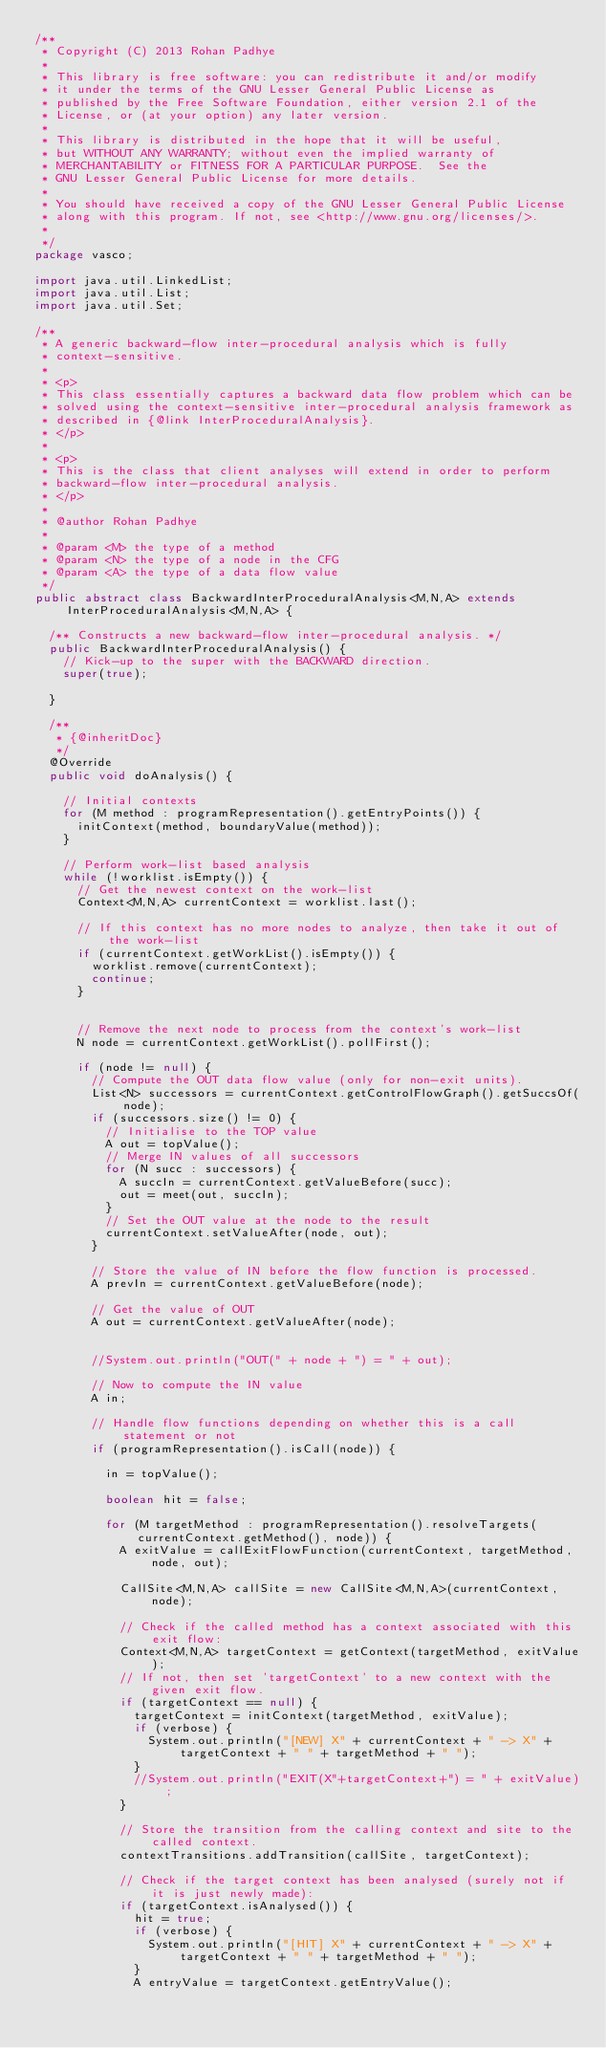<code> <loc_0><loc_0><loc_500><loc_500><_Java_>/**
 * Copyright (C) 2013 Rohan Padhye
 * 
 * This library is free software: you can redistribute it and/or modify
 * it under the terms of the GNU Lesser General Public License as 
 * published by the Free Software Foundation, either version 2.1 of the 
 * License, or (at your option) any later version.
 * 
 * This library is distributed in the hope that it will be useful,
 * but WITHOUT ANY WARRANTY; without even the implied warranty of
 * MERCHANTABILITY or FITNESS FOR A PARTICULAR PURPOSE.  See the
 * GNU Lesser General Public License for more details.
 * 
 * You should have received a copy of the GNU Lesser General Public License
 * along with this program. If not, see <http://www.gnu.org/licenses/>.
 * 
 */
package vasco;

import java.util.LinkedList;
import java.util.List;
import java.util.Set;

/**
 * A generic backward-flow inter-procedural analysis which is fully
 * context-sensitive.
 * 
 * <p>
 * This class essentially captures a backward data flow problem which can be
 * solved using the context-sensitive inter-procedural analysis framework as
 * described in {@link InterProceduralAnalysis}.
 * </p>
 * 
 * <p>
 * This is the class that client analyses will extend in order to perform
 * backward-flow inter-procedural analysis.
 * </p>
 * 
 * @author Rohan Padhye
 * 
 * @param <M> the type of a method
 * @param <N> the type of a node in the CFG
 * @param <A> the type of a data flow value
 */
public abstract class BackwardInterProceduralAnalysis<M,N,A> extends InterProceduralAnalysis<M,N,A> {

	/** Constructs a new backward-flow inter-procedural analysis. */
	public BackwardInterProceduralAnalysis() {
		// Kick-up to the super with the BACKWARD direction.
		super(true);

	}

	/**
	 * {@inheritDoc}
	 */
	@Override
	public void doAnalysis() {

		// Initial contexts
		for (M method : programRepresentation().getEntryPoints()) {
			initContext(method, boundaryValue(method));
		}

		// Perform work-list based analysis
		while (!worklist.isEmpty()) {
			// Get the newest context on the work-list
			Context<M,N,A> currentContext = worklist.last();
			
			// If this context has no more nodes to analyze, then take it out of the work-list
			if (currentContext.getWorkList().isEmpty()) {
				worklist.remove(currentContext);
				continue;
			}


			// Remove the next node to process from the context's work-list
			N node = currentContext.getWorkList().pollFirst();

			if (node != null) {
				// Compute the OUT data flow value (only for non-exit units).
				List<N> successors = currentContext.getControlFlowGraph().getSuccsOf(node);
				if (successors.size() != 0) {
					// Initialise to the TOP value
					A out = topValue();					
					// Merge IN values of all successors
					for (N succ : successors) {
						A succIn = currentContext.getValueBefore(succ);
						out = meet(out, succIn);
					}					
					// Set the OUT value at the node to the result
					currentContext.setValueAfter(node, out);
				}
				
				// Store the value of IN before the flow function is processed.
				A prevIn = currentContext.getValueBefore(node);
				
				// Get the value of OUT 
				A out = currentContext.getValueAfter(node);
				

				//System.out.println("OUT(" + node + ") = " + out);
				
				// Now to compute the IN value
				A in;
				
				// Handle flow functions depending on whether this is a call statement or not
				if (programRepresentation().isCall(node)) {
					
					in = topValue();
					
					boolean hit = false;
					
					for (M targetMethod : programRepresentation().resolveTargets(currentContext.getMethod(), node)) {
						A exitValue = callExitFlowFunction(currentContext, targetMethod, node, out);
						
						CallSite<M,N,A> callSite = new CallSite<M,N,A>(currentContext, node);
						
						// Check if the called method has a context associated with this exit flow:
						Context<M,N,A> targetContext = getContext(targetMethod, exitValue);
						// If not, then set 'targetContext' to a new context with the given exit flow.
						if (targetContext == null) {
							targetContext = initContext(targetMethod, exitValue);
							if (verbose) {
								System.out.println("[NEW] X" + currentContext + " -> X" + targetContext + " " + targetMethod + " ");
							}
							//System.out.println("EXIT(X"+targetContext+") = " + exitValue);
						}

						// Store the transition from the calling context and site to the called context.
						contextTransitions.addTransition(callSite, targetContext);

						// Check if the target context has been analysed (surely not if it is just newly made):
						if (targetContext.isAnalysed()) {
							hit = true;
							if (verbose) {
								System.out.println("[HIT] X" + currentContext + " -> X" + targetContext + " " + targetMethod + " ");
							}
							A entryValue = targetContext.getEntryValue();</code> 